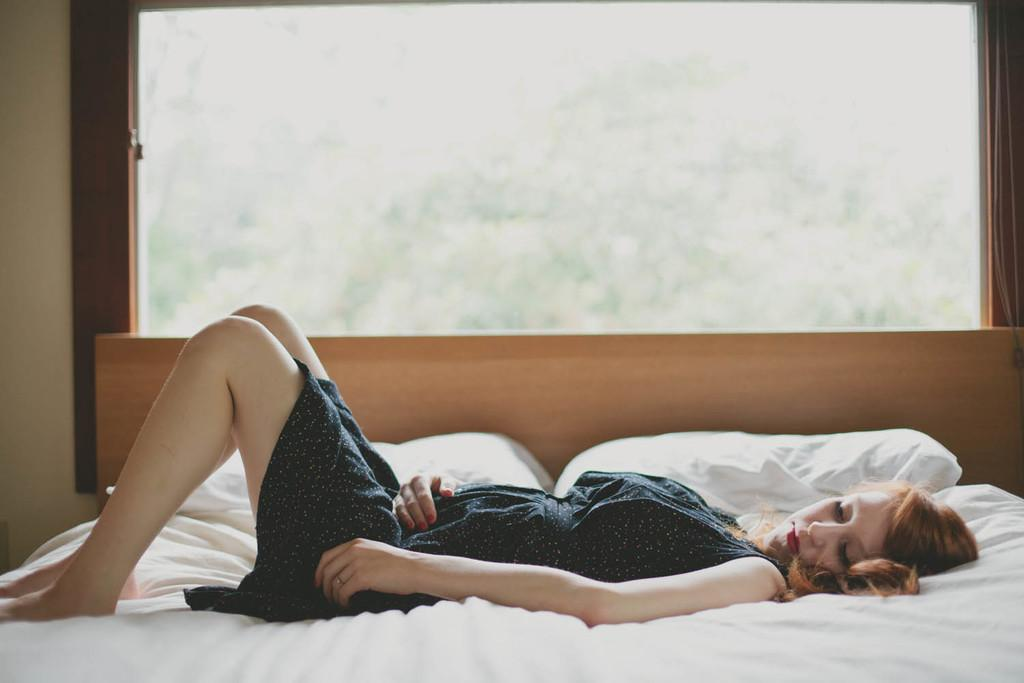Who is the main subject in the image? There is a woman in the image. What is the woman doing in the image? The woman is laying on a bed. Are there any objects near the woman on the bed? Yes, there are two pillows on her side of the bed. What type of soup is the woman eating in the image? There is no soup present in the image; the woman is laying on a bed with two pillows. 